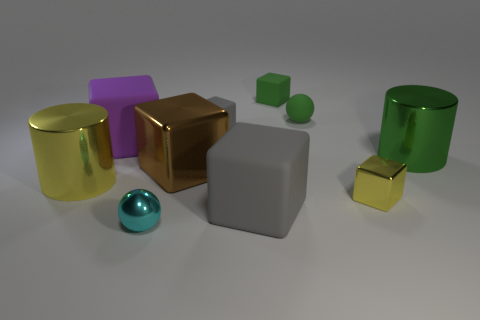Subtract all green matte cubes. How many cubes are left? 5 Subtract all balls. How many objects are left? 8 Subtract 1 cylinders. How many cylinders are left? 1 Add 4 balls. How many balls exist? 6 Subtract all yellow cubes. How many cubes are left? 5 Subtract 0 brown balls. How many objects are left? 10 Subtract all gray blocks. Subtract all gray cylinders. How many blocks are left? 4 Subtract all purple cubes. How many green cylinders are left? 1 Subtract all tiny blocks. Subtract all small green cubes. How many objects are left? 6 Add 5 big shiny objects. How many big shiny objects are left? 8 